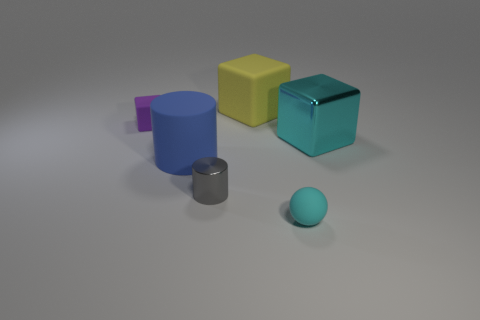Can you describe the lighting and shadows in the scene and what they suggest about the light source? The scene is lit with soft, diffuse light, casting gentle and slightly elongated shadows to the right of the objects. This suggests that the light source is to the left of the scene and possibly slightly elevated, as indicated by the direction and length of the shadows. The soft nature of the shadows indicates that the surroundings might be evenly lit, or the light source is not extremely bright or direct. 